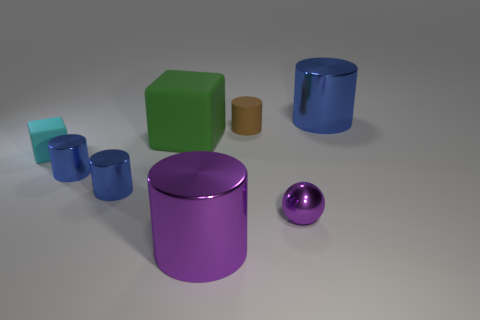Subtract all tiny blue cylinders. How many cylinders are left? 3 Subtract 4 cylinders. How many cylinders are left? 1 Subtract all green blocks. How many blocks are left? 1 Subtract all balls. How many objects are left? 7 Add 1 tiny purple shiny things. How many objects exist? 9 Add 7 tiny purple shiny spheres. How many tiny purple shiny spheres are left? 8 Add 6 balls. How many balls exist? 7 Subtract 0 yellow cylinders. How many objects are left? 8 Subtract all purple cylinders. Subtract all red cubes. How many cylinders are left? 4 Subtract all purple cylinders. How many gray balls are left? 0 